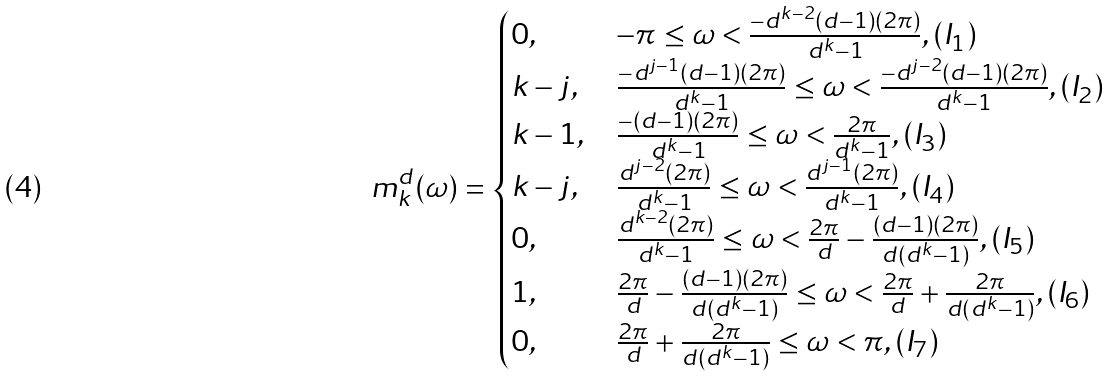<formula> <loc_0><loc_0><loc_500><loc_500>m _ { k } ^ { d } ( \omega ) = \begin{cases} 0 , & - \pi \leq \omega < \frac { - d ^ { k - 2 } ( d - 1 ) ( 2 \pi ) } { d ^ { k } - 1 } , ( I _ { 1 } ) \\ k - j , & \frac { - d ^ { j - 1 } ( d - 1 ) ( 2 \pi ) } { d ^ { k } - 1 } \leq \omega < \frac { - d ^ { j - 2 } ( d - 1 ) ( 2 \pi ) } { d ^ { k } - 1 } , ( I _ { 2 } ) \\ k - 1 , & \frac { - ( d - 1 ) ( 2 \pi ) } { d ^ { k } - 1 } \leq \omega < \frac { 2 \pi } { d ^ { k } - 1 } , ( I _ { 3 } ) \\ k - j , & \frac { d ^ { j - 2 } ( 2 \pi ) } { d ^ { k } - 1 } \leq \omega < \frac { d ^ { j - 1 } ( 2 \pi ) } { d ^ { k } - 1 } , ( I _ { 4 } ) \\ 0 , & \frac { d ^ { k - 2 } ( 2 \pi ) } { d ^ { k } - 1 } \leq \omega < \frac { 2 \pi } { d } - \frac { ( d - 1 ) ( 2 \pi ) } { d ( d ^ { k } - 1 ) } , ( I _ { 5 } ) \\ 1 , & \frac { 2 \pi } { d } - \frac { ( d - 1 ) ( 2 \pi ) } { d ( d ^ { k } - 1 ) } \leq \omega < \frac { 2 \pi } { d } + \frac { 2 \pi } { d ( d ^ { k } - 1 ) } , ( I _ { 6 } ) \\ 0 , & \frac { 2 \pi } { d } + \frac { 2 \pi } { d ( d ^ { k } - 1 ) } \leq \omega < \pi , ( I _ { 7 } ) \end{cases}</formula> 